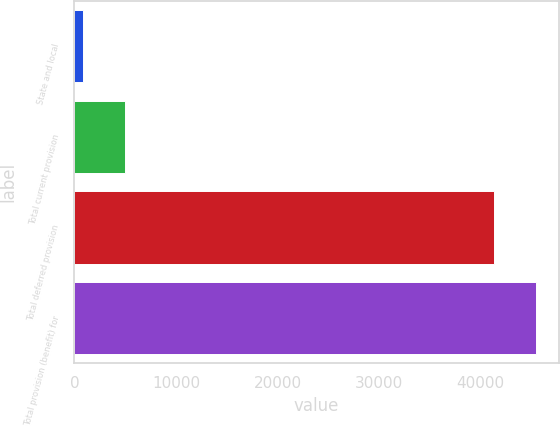Convert chart. <chart><loc_0><loc_0><loc_500><loc_500><bar_chart><fcel>State and local<fcel>Total current provision<fcel>Total deferred provision<fcel>Total provision (benefit) for<nl><fcel>895<fcel>5024<fcel>41290<fcel>45419<nl></chart> 